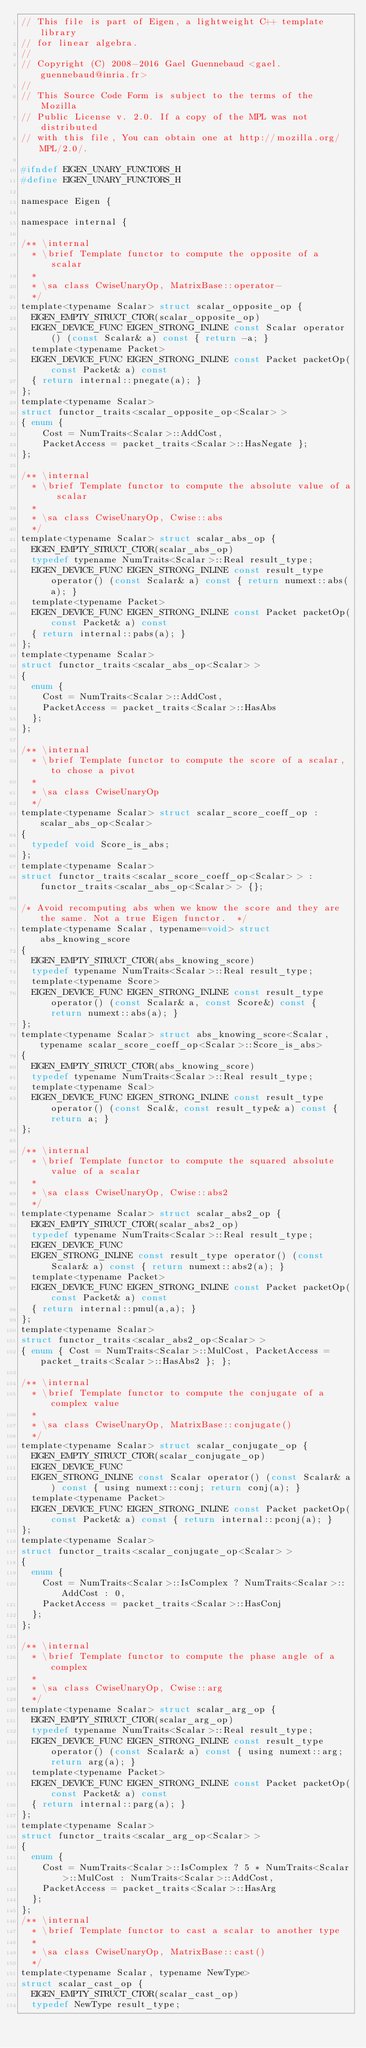Convert code to text. <code><loc_0><loc_0><loc_500><loc_500><_C_>// This file is part of Eigen, a lightweight C++ template library
// for linear algebra.
//
// Copyright (C) 2008-2016 Gael Guennebaud <gael.guennebaud@inria.fr>
//
// This Source Code Form is subject to the terms of the Mozilla
// Public License v. 2.0. If a copy of the MPL was not distributed
// with this file, You can obtain one at http://mozilla.org/MPL/2.0/.

#ifndef EIGEN_UNARY_FUNCTORS_H
#define EIGEN_UNARY_FUNCTORS_H

namespace Eigen {

namespace internal {

/** \internal
  * \brief Template functor to compute the opposite of a scalar
  *
  * \sa class CwiseUnaryOp, MatrixBase::operator-
  */
template<typename Scalar> struct scalar_opposite_op {
  EIGEN_EMPTY_STRUCT_CTOR(scalar_opposite_op)
  EIGEN_DEVICE_FUNC EIGEN_STRONG_INLINE const Scalar operator() (const Scalar& a) const { return -a; }
  template<typename Packet>
  EIGEN_DEVICE_FUNC EIGEN_STRONG_INLINE const Packet packetOp(const Packet& a) const
  { return internal::pnegate(a); }
};
template<typename Scalar>
struct functor_traits<scalar_opposite_op<Scalar> >
{ enum {
    Cost = NumTraits<Scalar>::AddCost,
    PacketAccess = packet_traits<Scalar>::HasNegate };
};

/** \internal
  * \brief Template functor to compute the absolute value of a scalar
  *
  * \sa class CwiseUnaryOp, Cwise::abs
  */
template<typename Scalar> struct scalar_abs_op {
  EIGEN_EMPTY_STRUCT_CTOR(scalar_abs_op)
  typedef typename NumTraits<Scalar>::Real result_type;
  EIGEN_DEVICE_FUNC EIGEN_STRONG_INLINE const result_type operator() (const Scalar& a) const { return numext::abs(a); }
  template<typename Packet>
  EIGEN_DEVICE_FUNC EIGEN_STRONG_INLINE const Packet packetOp(const Packet& a) const
  { return internal::pabs(a); }
};
template<typename Scalar>
struct functor_traits<scalar_abs_op<Scalar> >
{
  enum {
    Cost = NumTraits<Scalar>::AddCost,
    PacketAccess = packet_traits<Scalar>::HasAbs
  };
};

/** \internal
  * \brief Template functor to compute the score of a scalar, to chose a pivot
  *
  * \sa class CwiseUnaryOp
  */
template<typename Scalar> struct scalar_score_coeff_op : scalar_abs_op<Scalar>
{
  typedef void Score_is_abs;
};
template<typename Scalar>
struct functor_traits<scalar_score_coeff_op<Scalar> > : functor_traits<scalar_abs_op<Scalar> > {};

/* Avoid recomputing abs when we know the score and they are the same. Not a true Eigen functor.  */
template<typename Scalar, typename=void> struct abs_knowing_score
{
  EIGEN_EMPTY_STRUCT_CTOR(abs_knowing_score)
  typedef typename NumTraits<Scalar>::Real result_type;
  template<typename Score>
  EIGEN_DEVICE_FUNC EIGEN_STRONG_INLINE const result_type operator() (const Scalar& a, const Score&) const { return numext::abs(a); }
};
template<typename Scalar> struct abs_knowing_score<Scalar, typename scalar_score_coeff_op<Scalar>::Score_is_abs>
{
  EIGEN_EMPTY_STRUCT_CTOR(abs_knowing_score)
  typedef typename NumTraits<Scalar>::Real result_type;
  template<typename Scal>
  EIGEN_DEVICE_FUNC EIGEN_STRONG_INLINE const result_type operator() (const Scal&, const result_type& a) const { return a; }
};

/** \internal
  * \brief Template functor to compute the squared absolute value of a scalar
  *
  * \sa class CwiseUnaryOp, Cwise::abs2
  */
template<typename Scalar> struct scalar_abs2_op {
  EIGEN_EMPTY_STRUCT_CTOR(scalar_abs2_op)
  typedef typename NumTraits<Scalar>::Real result_type;
  EIGEN_DEVICE_FUNC
  EIGEN_STRONG_INLINE const result_type operator() (const Scalar& a) const { return numext::abs2(a); }
  template<typename Packet>
  EIGEN_DEVICE_FUNC EIGEN_STRONG_INLINE const Packet packetOp(const Packet& a) const
  { return internal::pmul(a,a); }
};
template<typename Scalar>
struct functor_traits<scalar_abs2_op<Scalar> >
{ enum { Cost = NumTraits<Scalar>::MulCost, PacketAccess = packet_traits<Scalar>::HasAbs2 }; };

/** \internal
  * \brief Template functor to compute the conjugate of a complex value
  *
  * \sa class CwiseUnaryOp, MatrixBase::conjugate()
  */
template<typename Scalar> struct scalar_conjugate_op {
  EIGEN_EMPTY_STRUCT_CTOR(scalar_conjugate_op)
  EIGEN_DEVICE_FUNC
  EIGEN_STRONG_INLINE const Scalar operator() (const Scalar& a) const { using numext::conj; return conj(a); }
  template<typename Packet>
  EIGEN_DEVICE_FUNC EIGEN_STRONG_INLINE const Packet packetOp(const Packet& a) const { return internal::pconj(a); }
};
template<typename Scalar>
struct functor_traits<scalar_conjugate_op<Scalar> >
{
  enum {
    Cost = NumTraits<Scalar>::IsComplex ? NumTraits<Scalar>::AddCost : 0,
    PacketAccess = packet_traits<Scalar>::HasConj
  };
};

/** \internal
  * \brief Template functor to compute the phase angle of a complex
  *
  * \sa class CwiseUnaryOp, Cwise::arg
  */
template<typename Scalar> struct scalar_arg_op {
  EIGEN_EMPTY_STRUCT_CTOR(scalar_arg_op)
  typedef typename NumTraits<Scalar>::Real result_type;
  EIGEN_DEVICE_FUNC EIGEN_STRONG_INLINE const result_type operator() (const Scalar& a) const { using numext::arg; return arg(a); }
  template<typename Packet>
  EIGEN_DEVICE_FUNC EIGEN_STRONG_INLINE const Packet packetOp(const Packet& a) const
  { return internal::parg(a); }
};
template<typename Scalar>
struct functor_traits<scalar_arg_op<Scalar> >
{
  enum {
    Cost = NumTraits<Scalar>::IsComplex ? 5 * NumTraits<Scalar>::MulCost : NumTraits<Scalar>::AddCost,
    PacketAccess = packet_traits<Scalar>::HasArg
  };
};
/** \internal
  * \brief Template functor to cast a scalar to another type
  *
  * \sa class CwiseUnaryOp, MatrixBase::cast()
  */
template<typename Scalar, typename NewType>
struct scalar_cast_op {
  EIGEN_EMPTY_STRUCT_CTOR(scalar_cast_op)
  typedef NewType result_type;</code> 